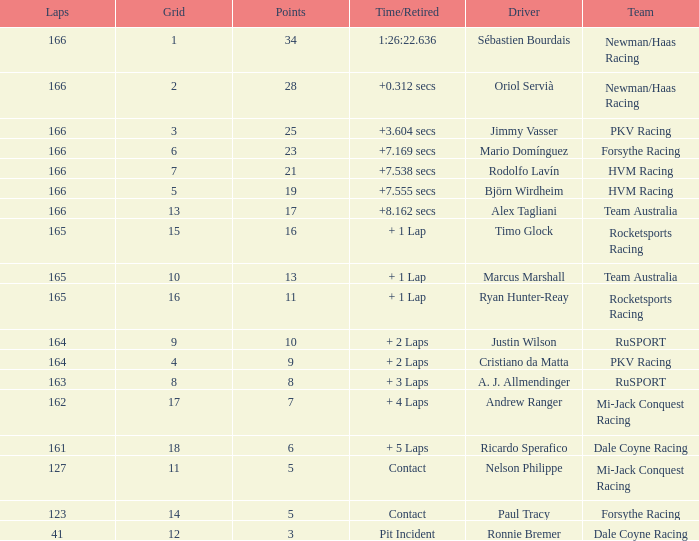What is the average points that the driver Ryan Hunter-Reay has? 11.0. 